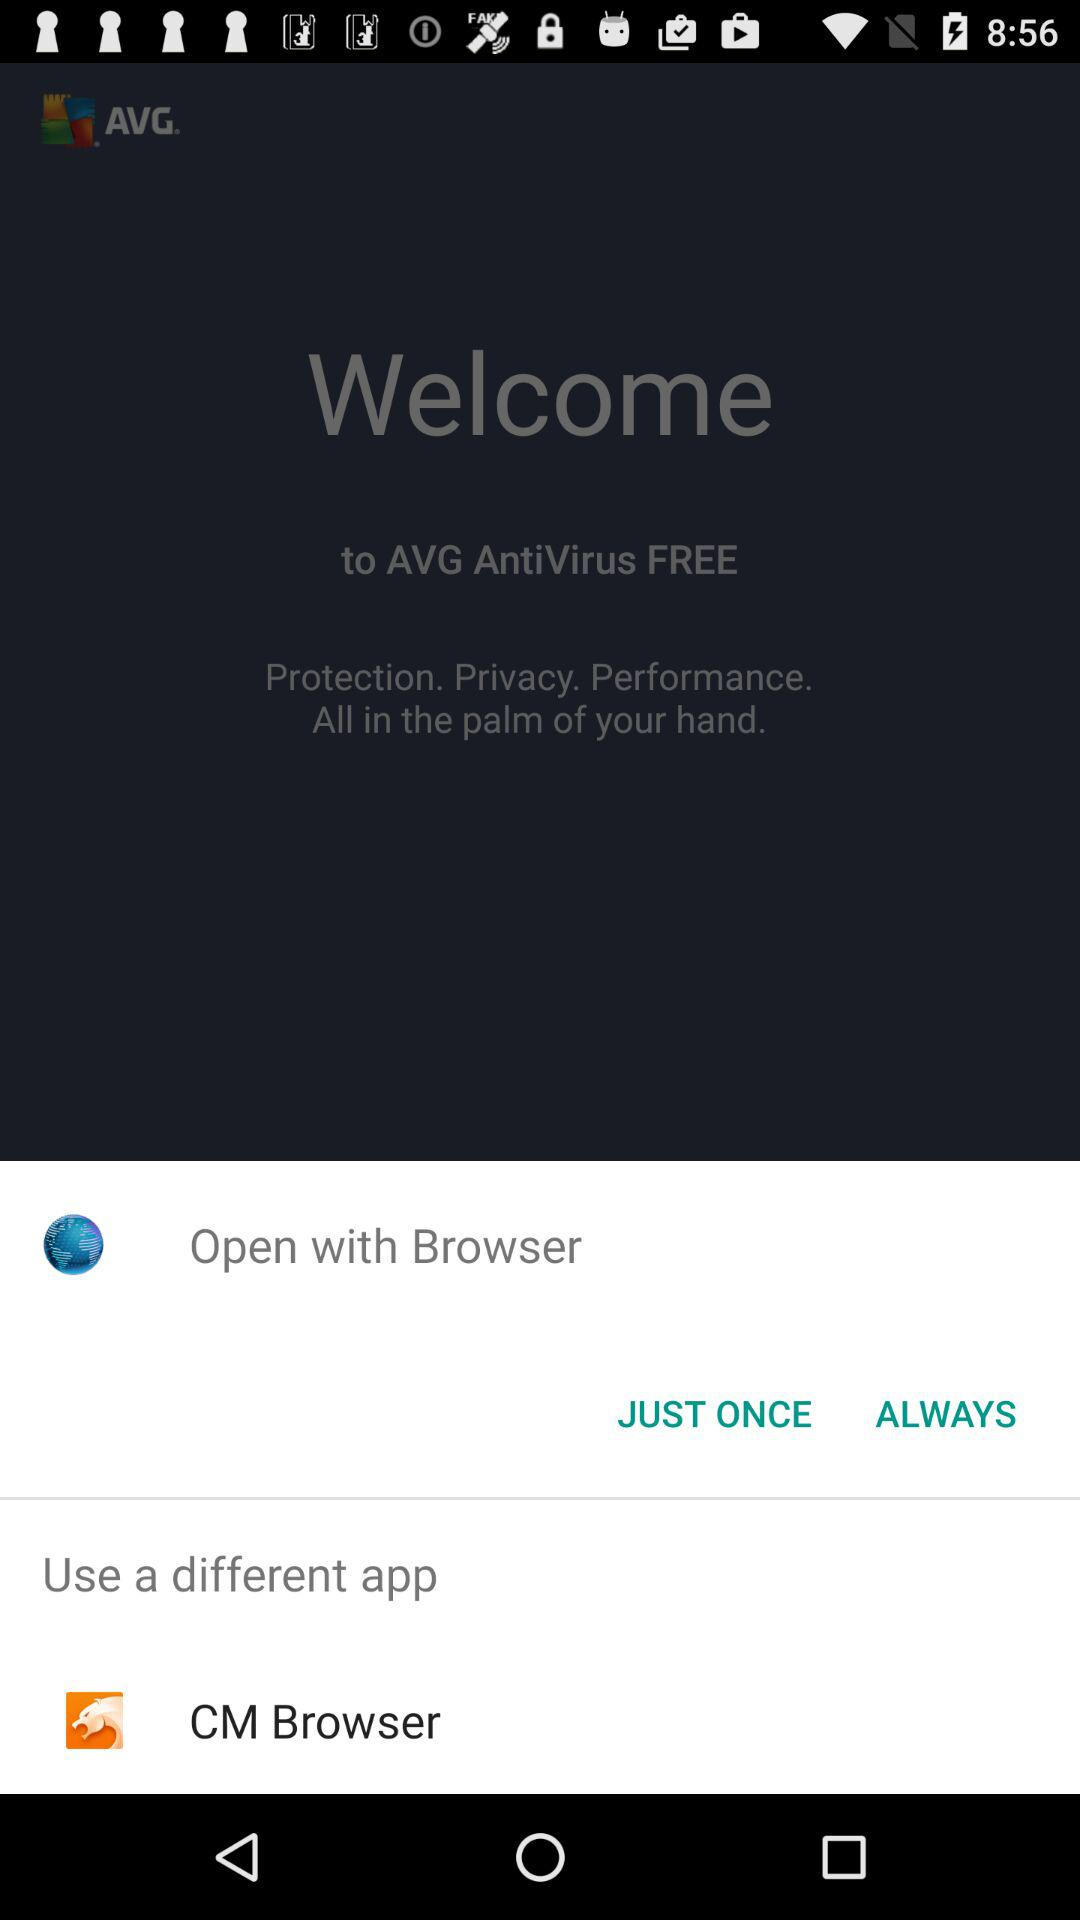Which different applications can we use to open? You can use the "CM Browser" application. 